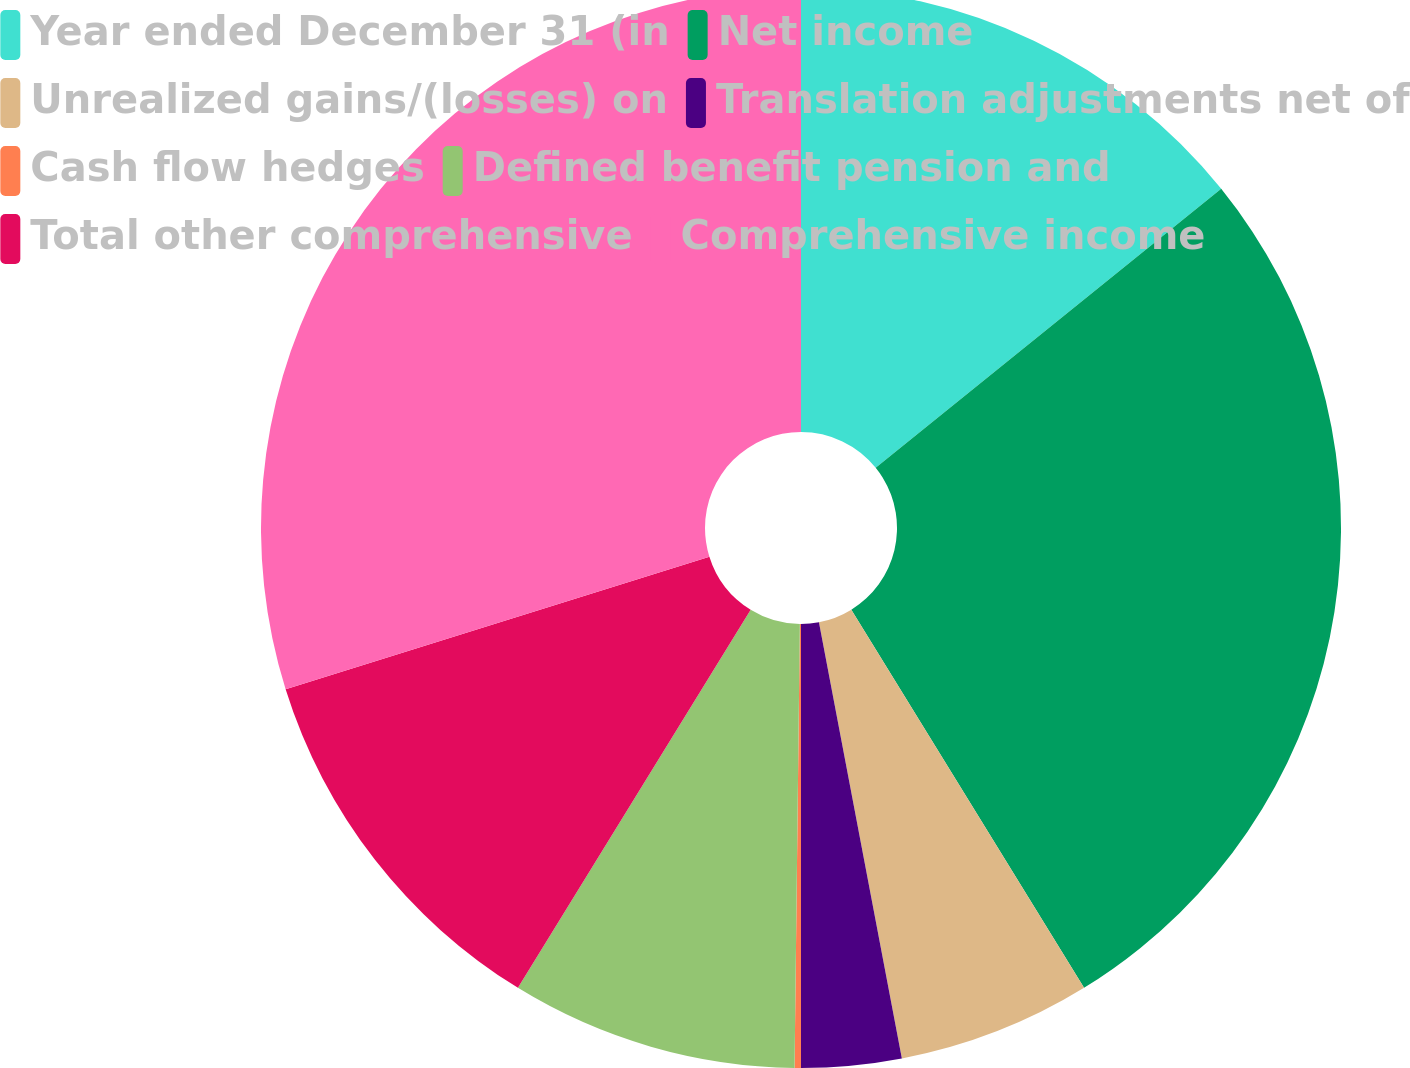Convert chart. <chart><loc_0><loc_0><loc_500><loc_500><pie_chart><fcel>Year ended December 31 (in<fcel>Net income<fcel>Unrealized gains/(losses) on<fcel>Translation adjustments net of<fcel>Cash flow hedges<fcel>Defined benefit pension and<fcel>Total other comprehensive<fcel>Comprehensive income<nl><fcel>14.19%<fcel>27.02%<fcel>5.79%<fcel>2.99%<fcel>0.19%<fcel>8.59%<fcel>11.39%<fcel>29.82%<nl></chart> 